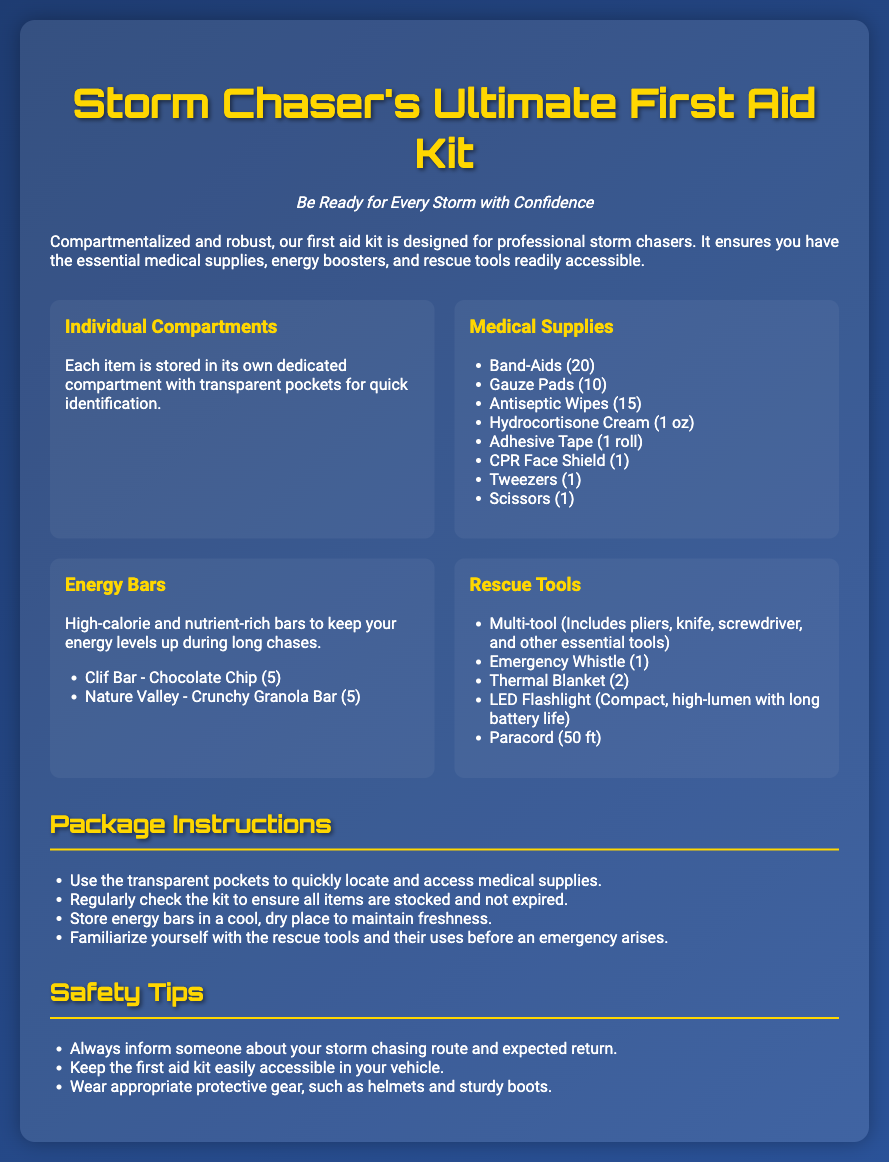What is the name of the product? The product is titled at the top of the document, which describes it as a first aid kit specifically for storm chasers.
Answer: Storm Chaser's Ultimate First Aid Kit How many Band-Aids are included? The number of Band-Aids is listed under the Medical Supplies section of the document.
Answer: 20 What are the energy bar brands included in the kit? The brands of energy bars are mentioned in the Energy Bars section, highlighting specific types.
Answer: Clif Bar, Nature Valley How many transparent pockets are there? The document describes individual compartments with transparent pockets but does not specify the exact number.
Answer: Not specified What is the purpose of the rescue tools? The document explains that the rescue tools are included to assist in emergency situations, implying their necessity.
Answer: Emergency situations How are the medical supplies stored? The document states that each item is stored in its own dedicated compartment, ensuring organized access.
Answer: Individual Compartments What should you do to ensure freshness of energy bars? The document provides a specific instruction focused on the storage of energy bars to maintain their condition.
Answer: Store in a cool, dry place What is a safety tip mentioned in the document? The document lists safety tips, one of which relates to communication about storm chasing routes.
Answer: Inform someone about your storm chasing route What is the color of the text headers? The color of the headings is explicitly stated in the document, indicating a design choice.
Answer: Gold 